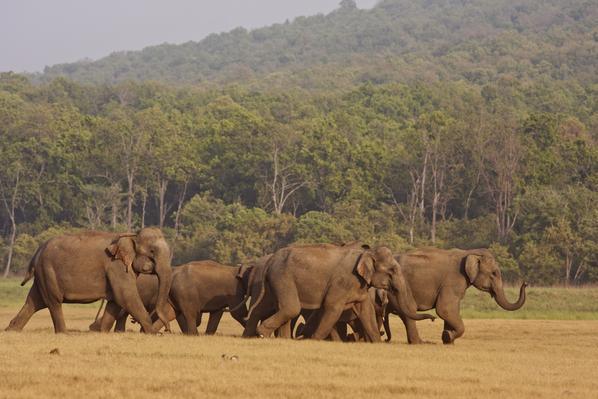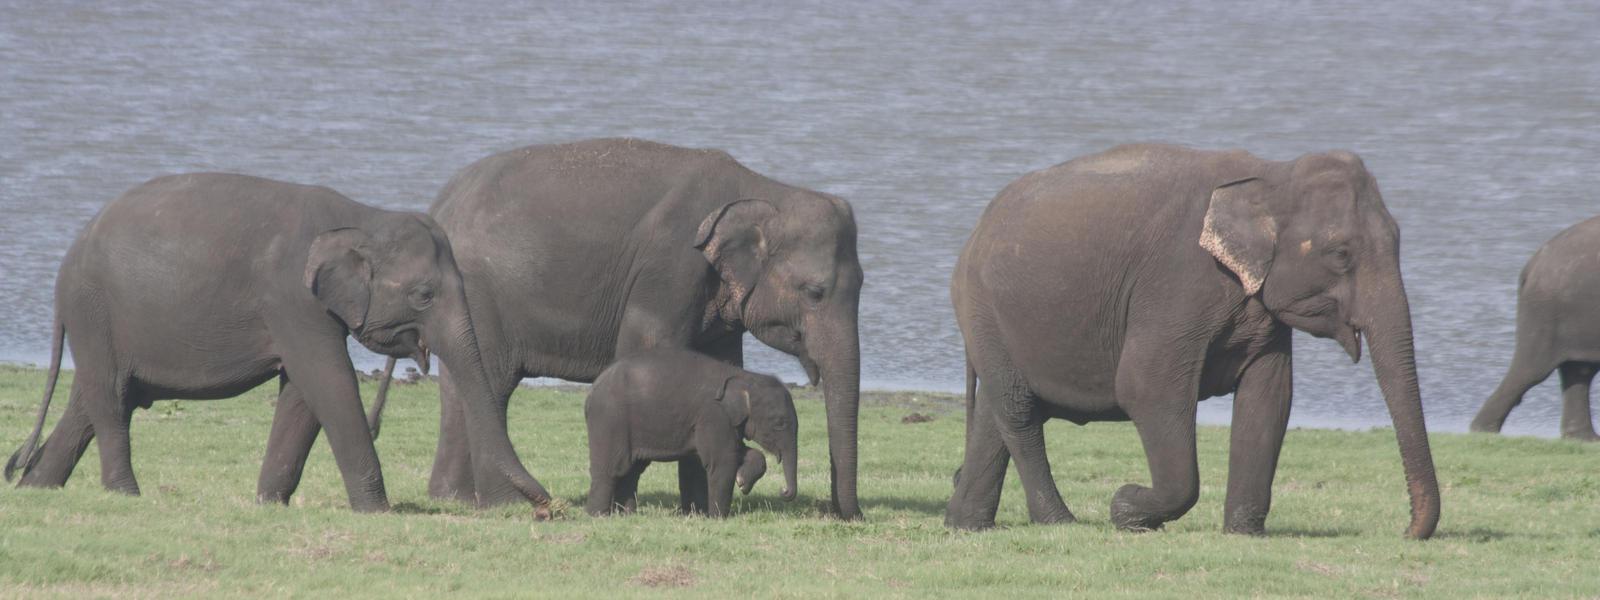The first image is the image on the left, the second image is the image on the right. For the images displayed, is the sentence "One image shows one gray baby elephant walking with no more than three adults." factually correct? Answer yes or no. Yes. The first image is the image on the left, the second image is the image on the right. Given the left and right images, does the statement "All elephants are headed in the same direction." hold true? Answer yes or no. Yes. 